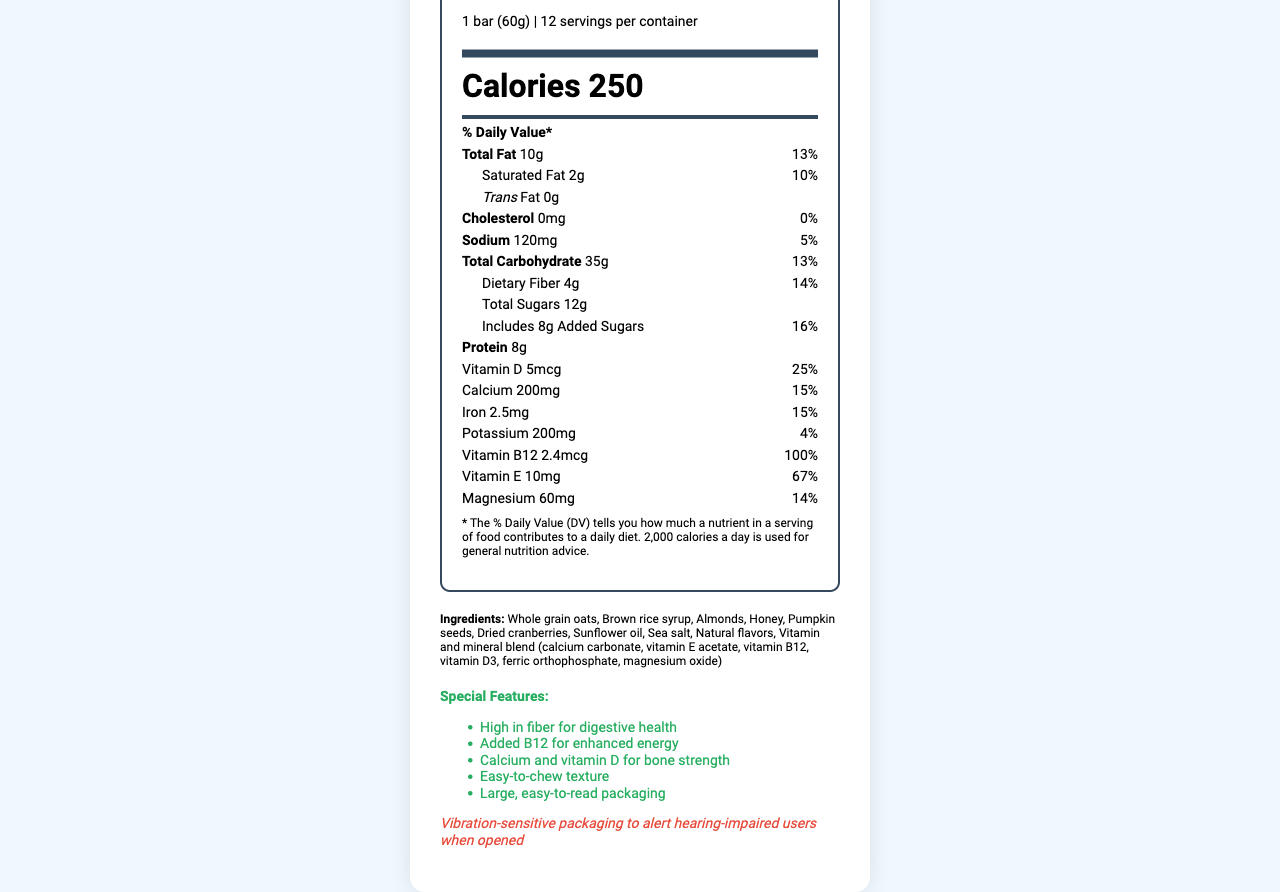what is the serving size of the ActiveSenior Granola Boost Bar? The serving size is mentioned at the very top of the nutrition information.
Answer: 1 bar (60g) how many calories are there per serving? The calorie count is listed prominently in the middle of the nutrition facts.
Answer: 250 what is the percentage of daily value for Vitamin B12 in one serving? The % Daily Value for Vitamin B12 is listed next to its amount in the nutrition facts section.
Answer: 100% which ingredient is listed first among the granola bar ingredients? Ingredients are listed in descending order by weight, and the first ingredient is Whole grain oats.
Answer: Whole grain oats how much trans fat does the granola bar contain? The amount of trans fat is clearly labeled as 0g in the nutrition facts.
Answer: 0g what is the manufacturing company of the granola bar? It is stated in the manufacturer information section.
Answer: SeniorWell Nutrition how much protein is in one serving? The amount of protein per serving is specified in the nutrition facts.
Answer: 8g how much dietary fiber is in one serving and what is the daily value percentage? The amount and daily value percentage of dietary fiber are listed in the nutrition facts.
Answer: 4g and 14% what are some special features of the product? A. High in fiber B. Contains artificial flavors C. Added B12 D. Contains caffeine The special features include being high in fiber and added B12, but it does not contain artificial flavors or caffeine.
Answer: A, C what does the document say about the packaging alert feature? A. It's color-coded B. It's vibration-sensitive C. It has a loud sound The document notes that the packaging is vibration-sensitive to alert hearing-impaired users.
Answer: B does the product contain any cholesterol? The nutrition facts show 0mg of cholesterol.
Answer: No summarize the main idea of the document. The document is focused on giving detailed nutritional information about the granola bar, highlighting its benefits for active seniors, including added vitamins and user-friendly packaging.
Answer: The document provides comprehensive nutrition facts and additional features of the ActiveSenior Granola Boost Bar. It outlines serving size, caloric content, nutrient amounts, special features, and packaging designed for hearing-impaired users. what is the address of the manufacturer? The document provides the manufacturer's name (SeniorWell Nutrition) but does not provide the address.
Answer: Cannot be determined 